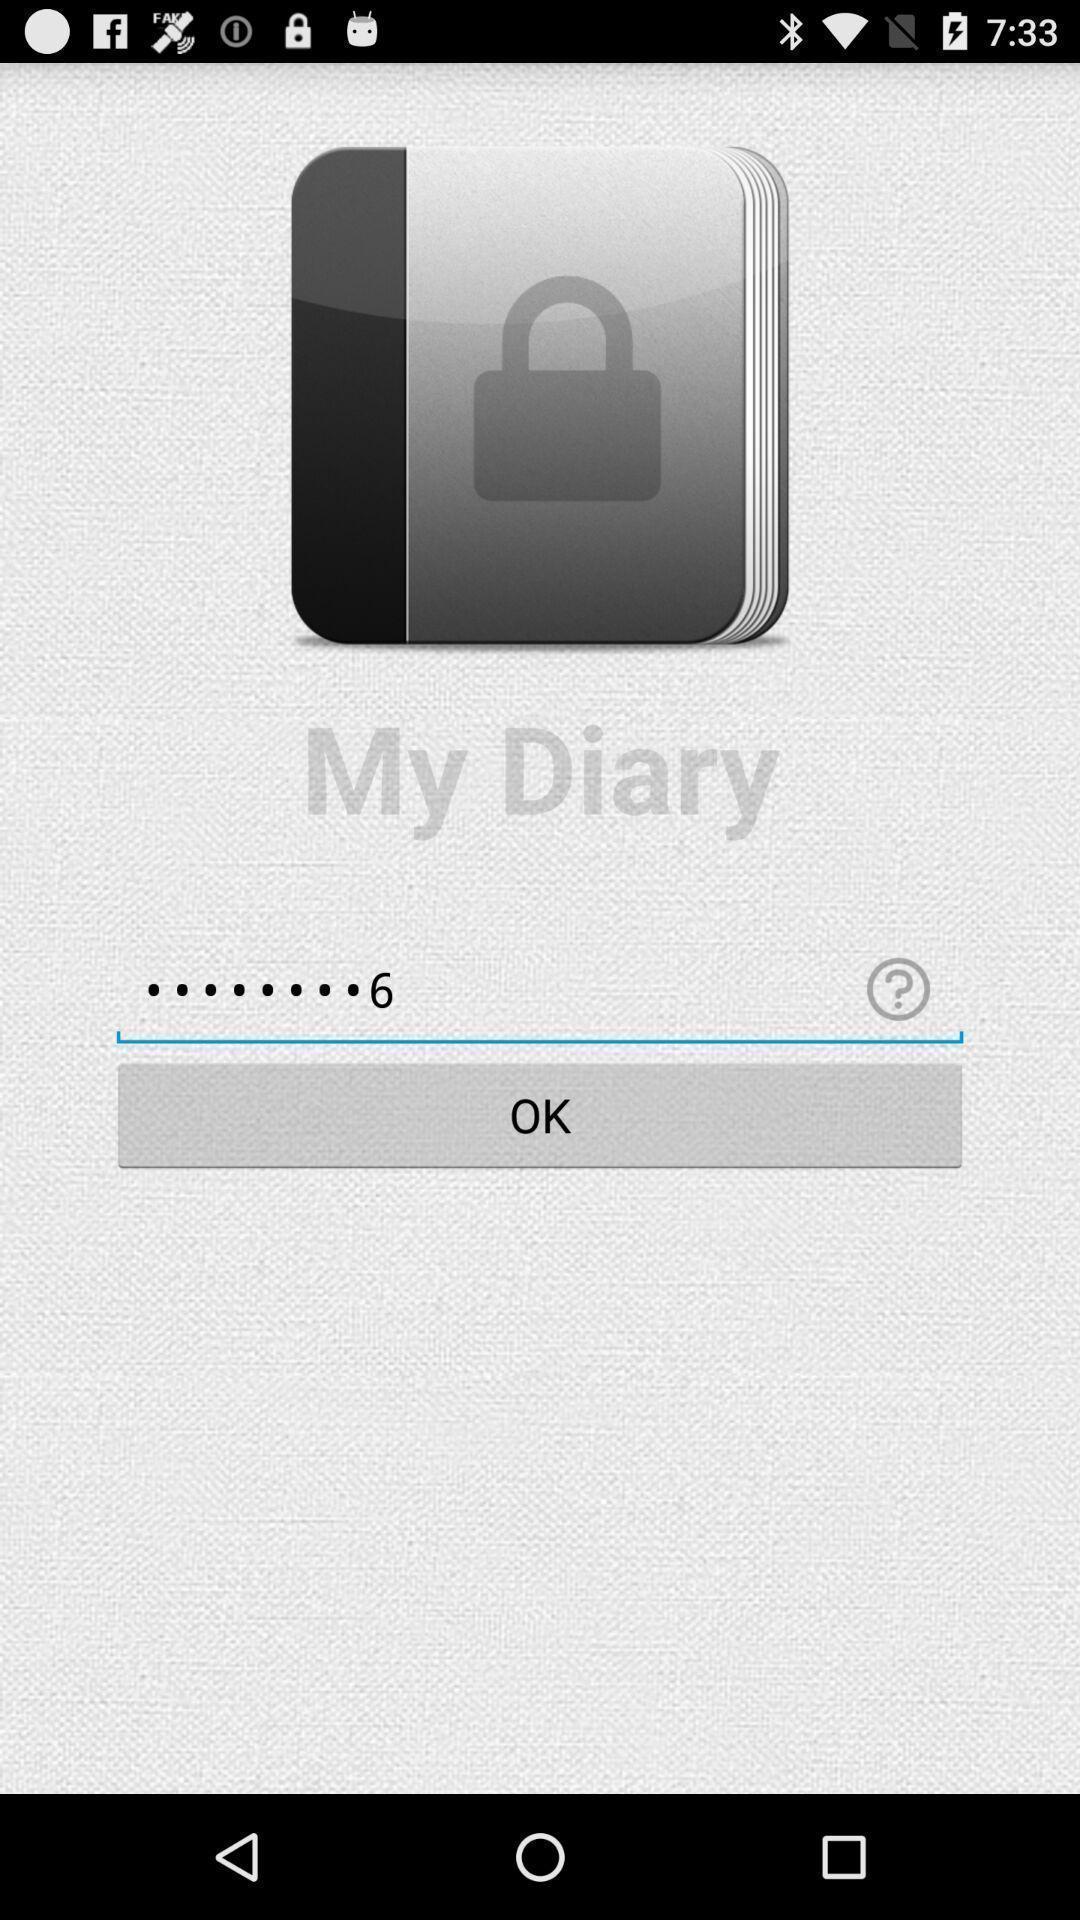Tell me what you see in this picture. Welcome page of notes application. 